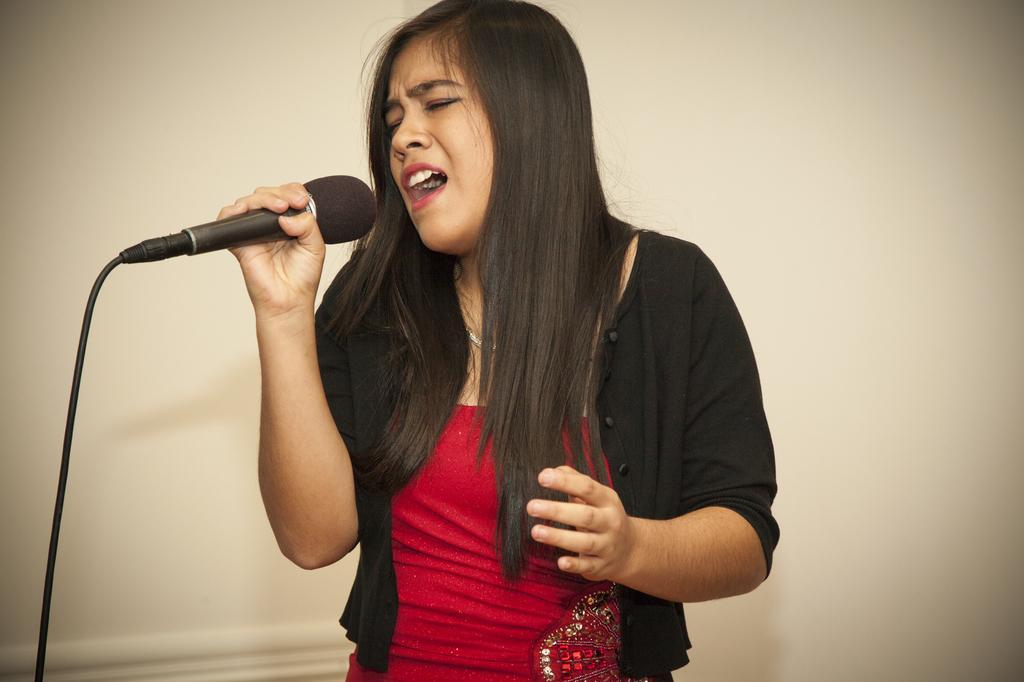Describe this image in one or two sentences. In this image I can see a woman is holding a mic. I can also see she is wearing a shrug. 